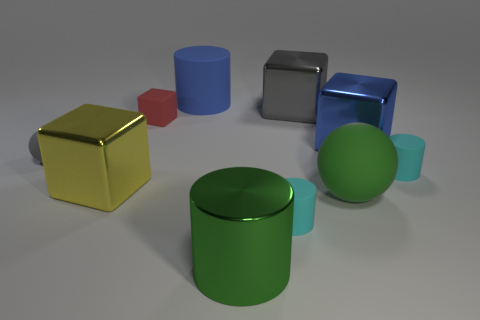Subtract all large green cylinders. How many cylinders are left? 3 Subtract all spheres. How many objects are left? 8 Subtract all small yellow matte objects. Subtract all tiny gray objects. How many objects are left? 9 Add 1 blue rubber cylinders. How many blue rubber cylinders are left? 2 Add 6 blue matte objects. How many blue matte objects exist? 7 Subtract 1 green cylinders. How many objects are left? 9 